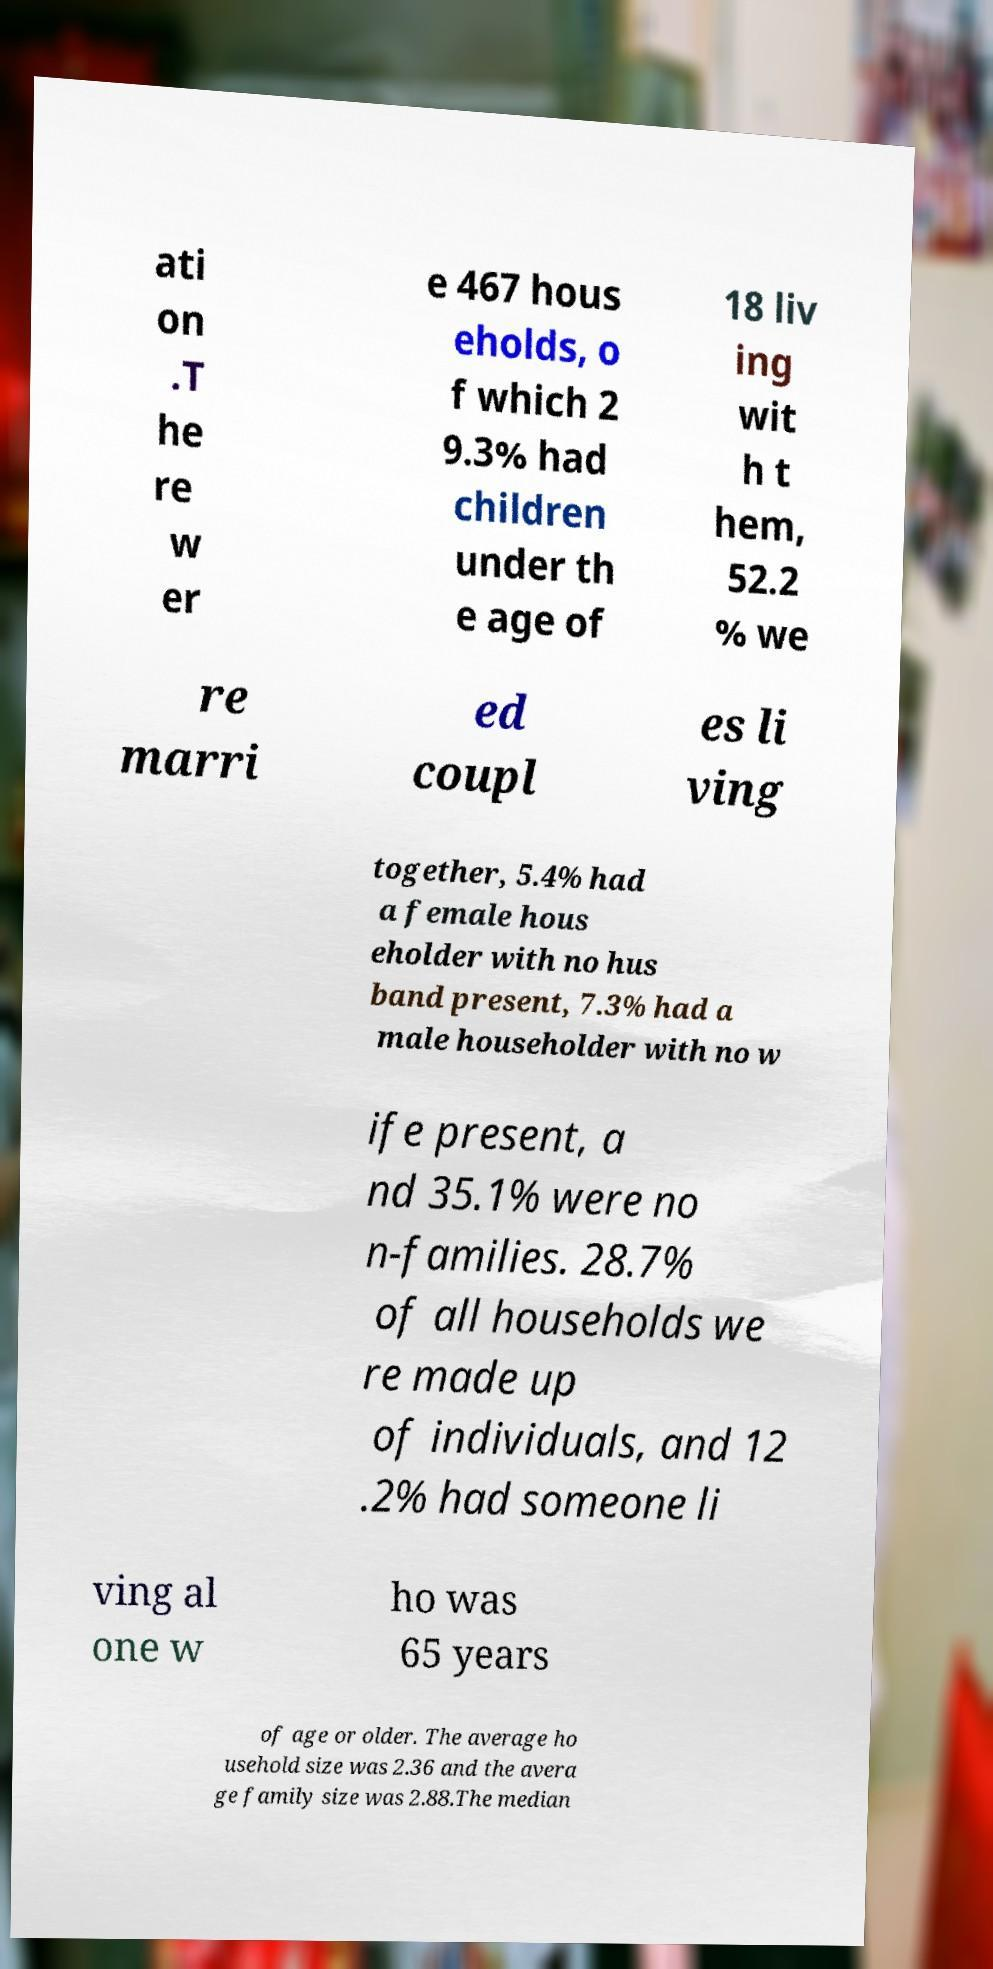What messages or text are displayed in this image? I need them in a readable, typed format. ati on .T he re w er e 467 hous eholds, o f which 2 9.3% had children under th e age of 18 liv ing wit h t hem, 52.2 % we re marri ed coupl es li ving together, 5.4% had a female hous eholder with no hus band present, 7.3% had a male householder with no w ife present, a nd 35.1% were no n-families. 28.7% of all households we re made up of individuals, and 12 .2% had someone li ving al one w ho was 65 years of age or older. The average ho usehold size was 2.36 and the avera ge family size was 2.88.The median 